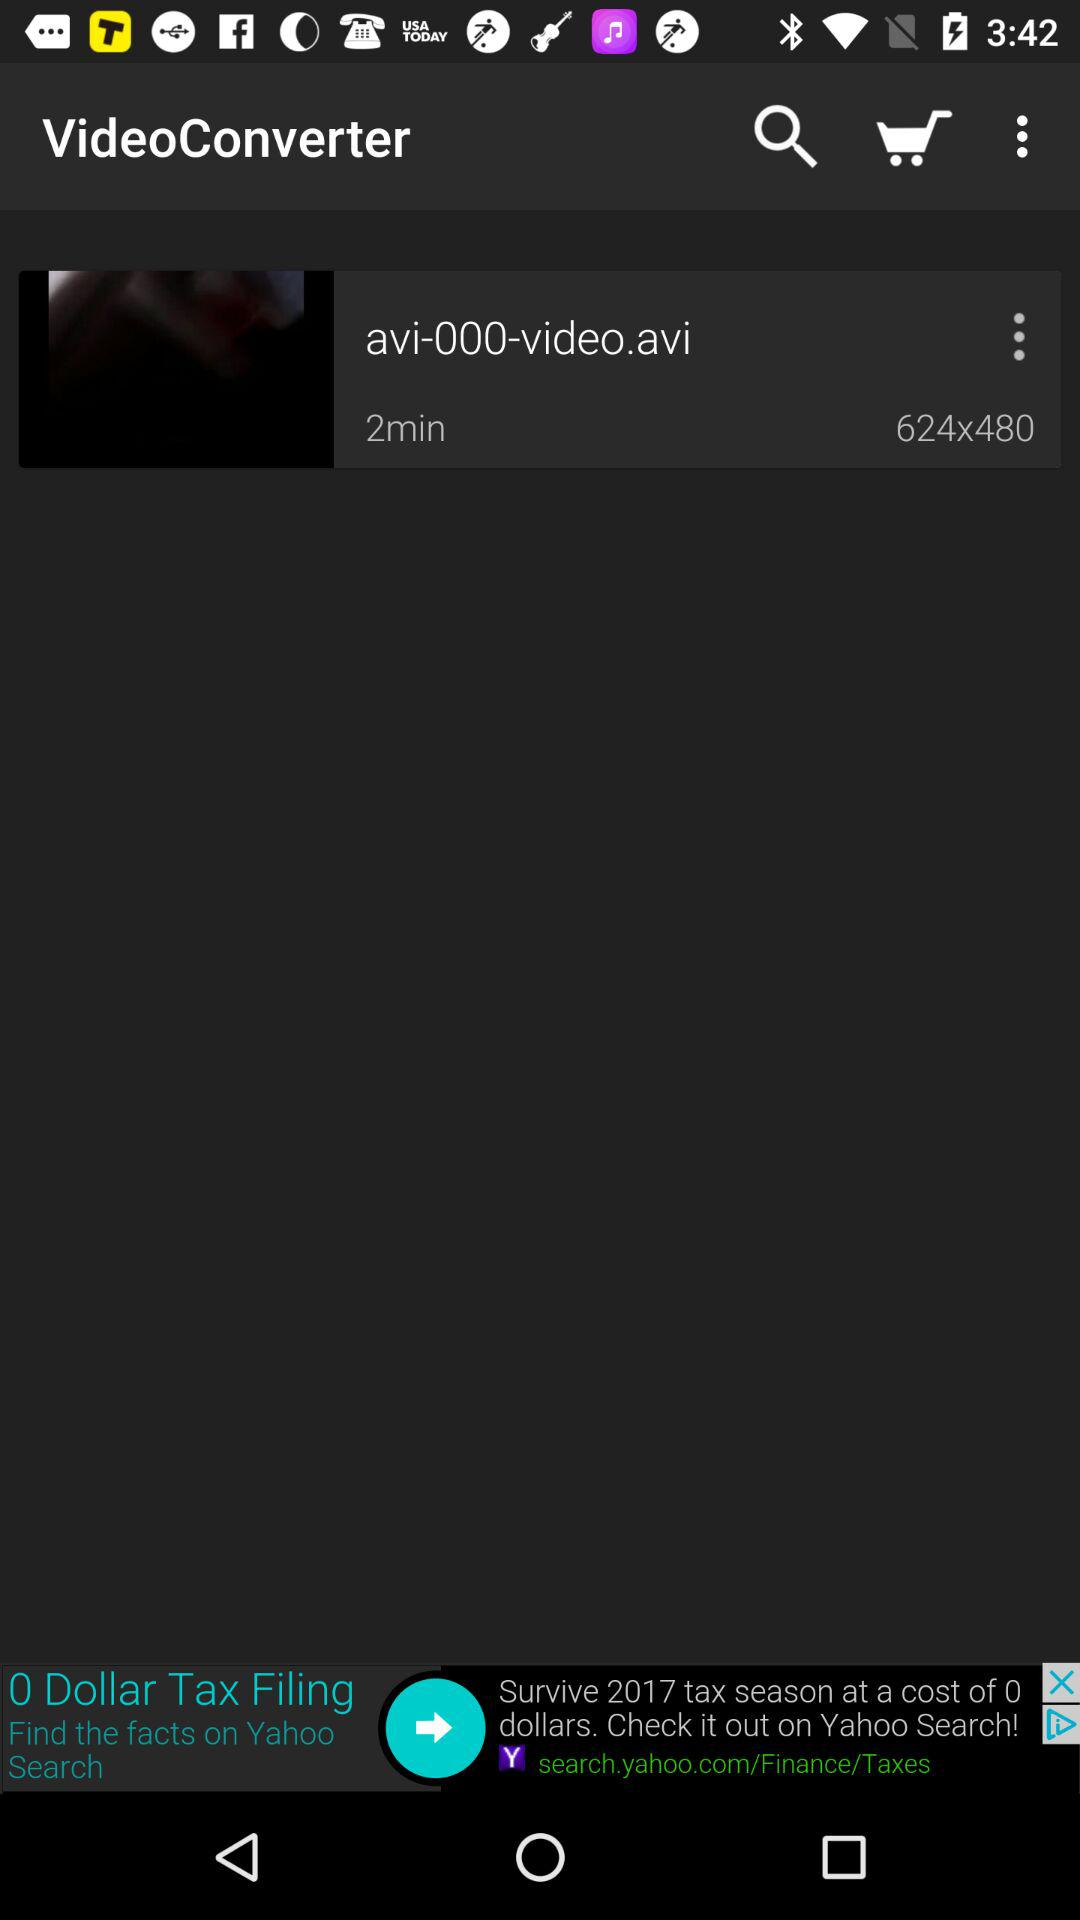What are the dimensions of the video file? The dimensions of the video file are 624x480. 